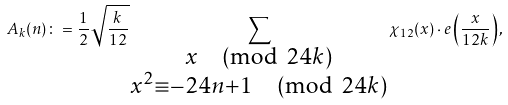<formula> <loc_0><loc_0><loc_500><loc_500>A _ { k } ( n ) \colon = \frac { 1 } { 2 } \sqrt { \frac { k } { 1 2 } } \sum _ { \substack { x \pmod { 2 4 k } \\ x ^ { 2 } \equiv - 2 4 n + 1 \pmod { 2 4 k } } } \chi _ { 1 2 } ( x ) \cdot e \left ( \frac { x } { 1 2 k } \right ) ,</formula> 